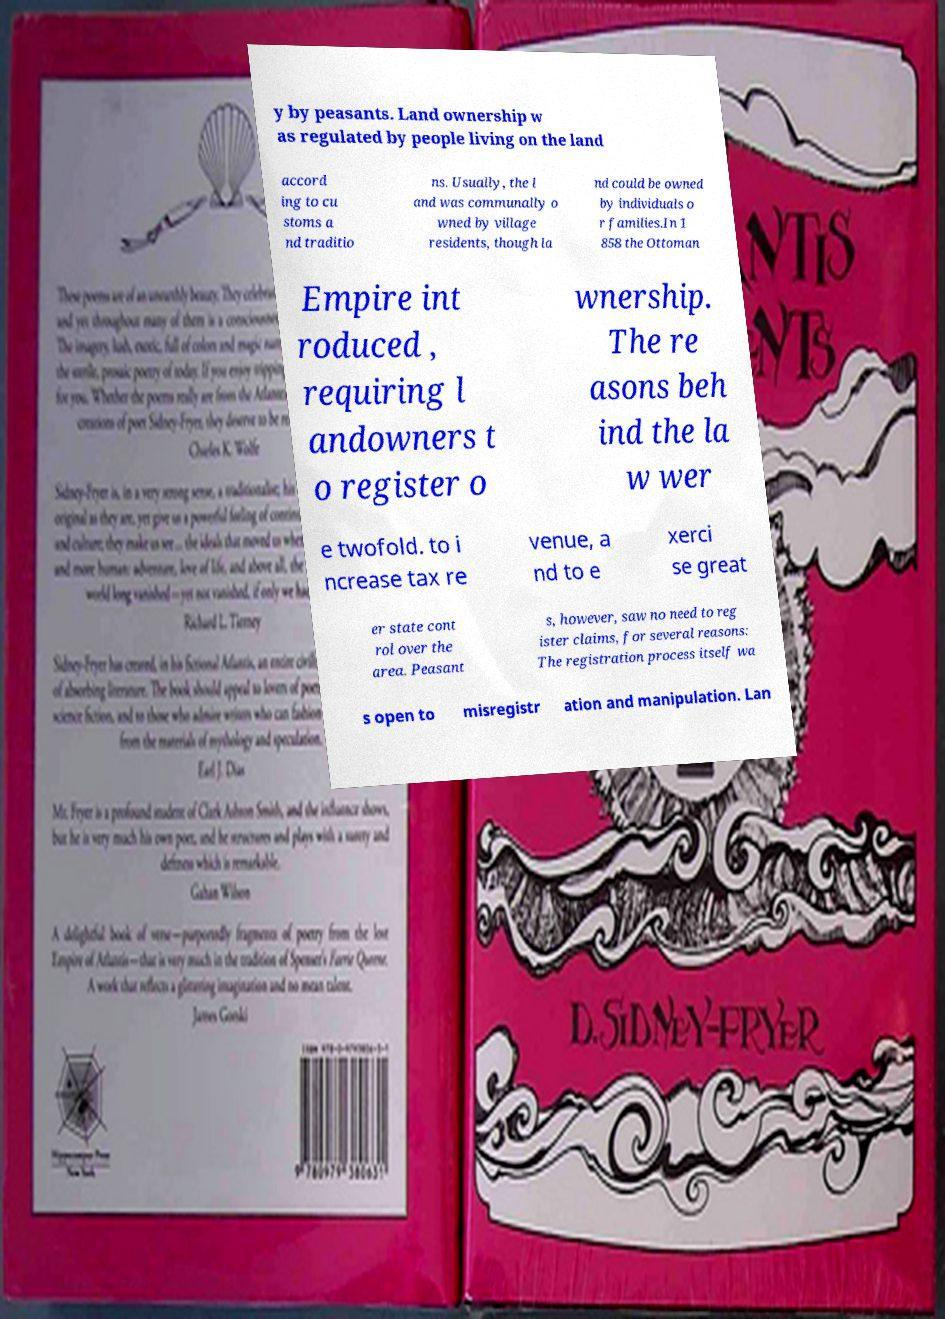I need the written content from this picture converted into text. Can you do that? y by peasants. Land ownership w as regulated by people living on the land accord ing to cu stoms a nd traditio ns. Usually, the l and was communally o wned by village residents, though la nd could be owned by individuals o r families.In 1 858 the Ottoman Empire int roduced , requiring l andowners t o register o wnership. The re asons beh ind the la w wer e twofold. to i ncrease tax re venue, a nd to e xerci se great er state cont rol over the area. Peasant s, however, saw no need to reg ister claims, for several reasons: The registration process itself wa s open to misregistr ation and manipulation. Lan 